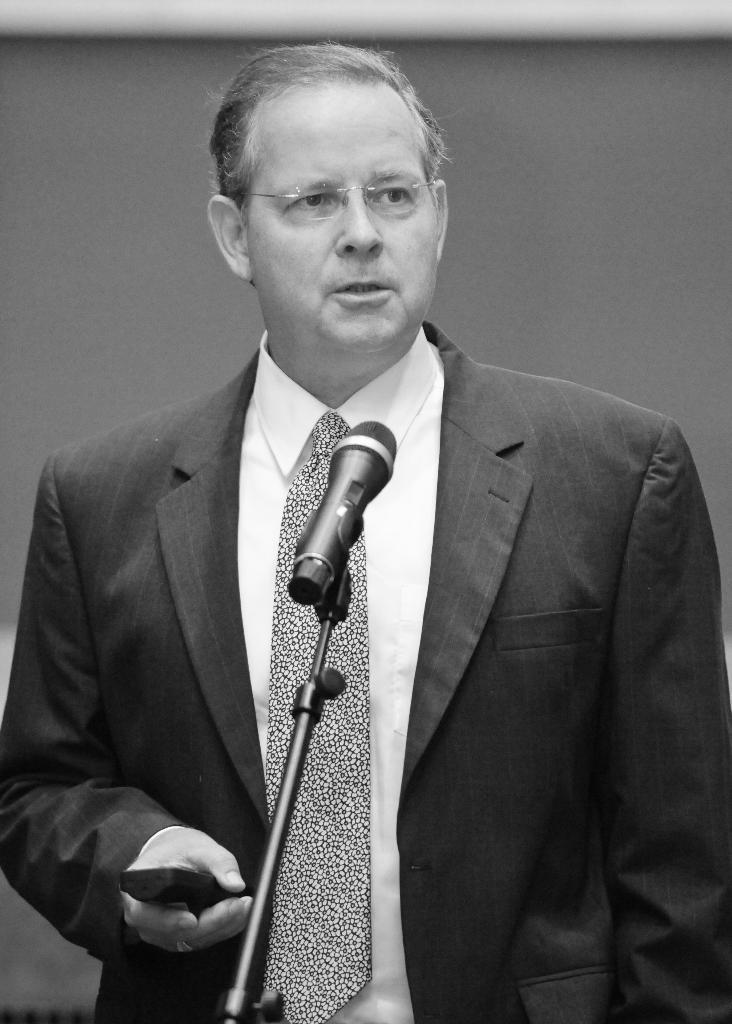What is the main subject of the image? There is a person standing in the image. Can you describe the person's appearance? The person is wearing spectacles. What object is present in the image that is typically used for amplifying sound? There is a microphone in the image. What type of structure can be seen in the background of the image? There is a wall in the image. What type of cloth is draped over the boundary in the image? There is no cloth or boundary present in the image. What show is the person attending in the image? The image does not provide any information about a show or event that the person might be attending. 